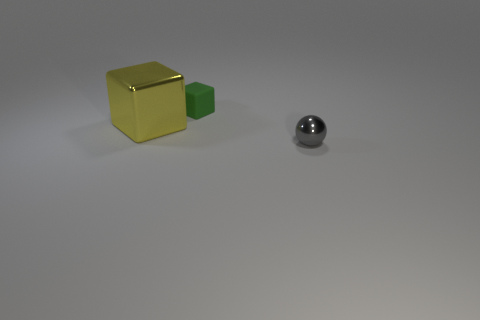What is the small gray ball made of?
Your answer should be very brief. Metal. How many balls are either yellow shiny things or tiny green matte things?
Your answer should be compact. 0. Is the material of the big yellow object the same as the tiny cube?
Provide a short and direct response. No. The other thing that is the same shape as the tiny green rubber object is what size?
Your answer should be compact. Large. What is the material of the thing that is on the right side of the big yellow shiny cube and behind the small gray thing?
Keep it short and to the point. Rubber. Is the number of things that are left of the small green thing the same as the number of large yellow shiny cylinders?
Offer a very short reply. No. How many things are either metal objects to the left of the gray ball or tiny gray things?
Your response must be concise. 2. Do the tiny thing that is behind the metal sphere and the ball have the same color?
Provide a succinct answer. No. How big is the block left of the tiny cube?
Provide a succinct answer. Large. There is a rubber object that is right of the shiny thing left of the tiny metal sphere; what shape is it?
Offer a terse response. Cube. 